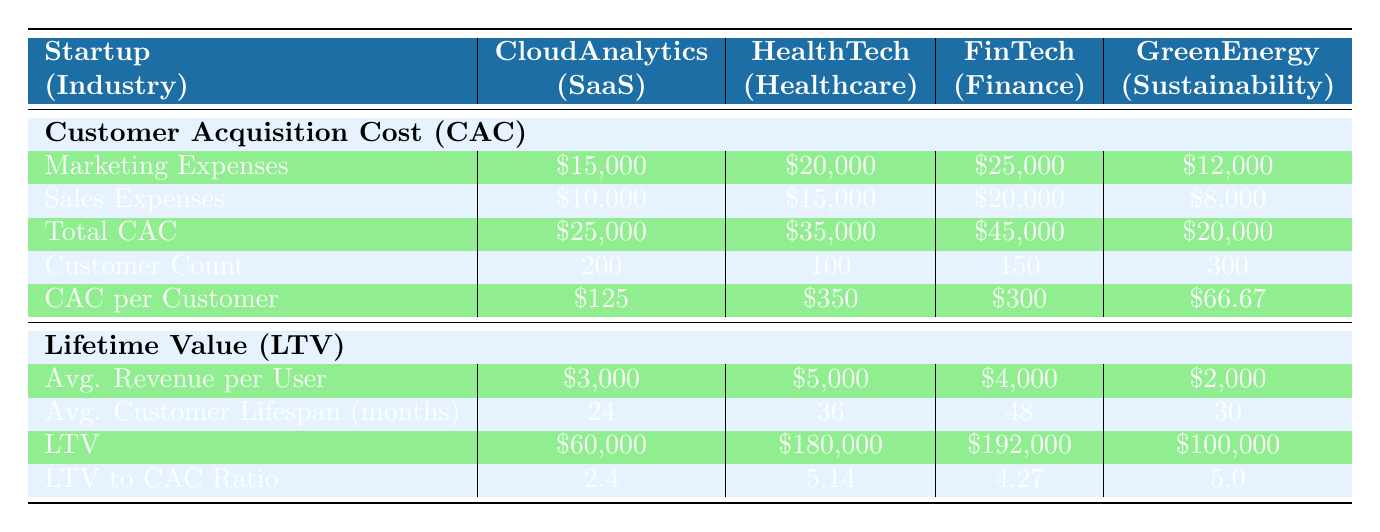What is the total customer acquisition cost for HealthTech Innovations? According to the table, the total customer acquisition cost for HealthTech Innovations is listed directly under the Customer Acquisition Cost (CAC) section as $35,000.
Answer: $35,000 What is the average revenue per user for FinTech Solutions? The average revenue per user for FinTech Solutions is found under the Lifetime Value (LTV) section specifically stating $4,000.
Answer: $4,000 Which startup has the lowest customer acquisition cost per customer? By comparing the CAC per Customer values across the four startups, GreenEnergy Tech has the lowest value at $66.67, while the others have higher CACs per customer.
Answer: GreenEnergy Tech What is the LTV to CAC ratio for CloudAnalytics Inc.? Looking at the Lifetime Value section for CloudAnalytics Inc., the LTV to CAC ratio is 2.4, which indicates the relationship between how much value a customer brings versus the acquisition cost.
Answer: 2.4 If we sum the average revenue per user across all startups, what is the total? To find the total average revenue, we add the values: $3,000 (CloudAnalytics) + $5,000 (HealthTech) + $4,000 (FinTech) + $2,000 (GreenEnergy) which equals $14,000.
Answer: $14,000 Is the lifetime value (LTV) for GreenEnergy Tech greater than its total customer acquisition cost (CAC)? The lifetime value for GreenEnergy Tech is $100,000, which is indeed greater than its total customer acquisition cost of $20,000, confirming that the LTV exceeds CAC.
Answer: Yes What is the average customer lifespan for HealthTech Innovations in months? The average customer lifespan for HealthTech Innovations is available in the LTV section, noted as 36 months.
Answer: 36 months Which startup has the highest LTV to CAC ratio, and what is that ratio? By comparing the LTV to CAC ratios, HealthTech Innovations has the highest ratio at 5.14, indicating its strong profitability in relation to acquisition costs.
Answer: HealthTech Innovations, 5.14 What is the total marketing expenses for all four startups combined? The total marketing expenses are calculated by adding: $15,000 (CloudAnalytics) + $20,000 (HealthTech) + $25,000 (FinTech) + $12,000 (GreenEnergy), resulting in $72,000.
Answer: $72,000 